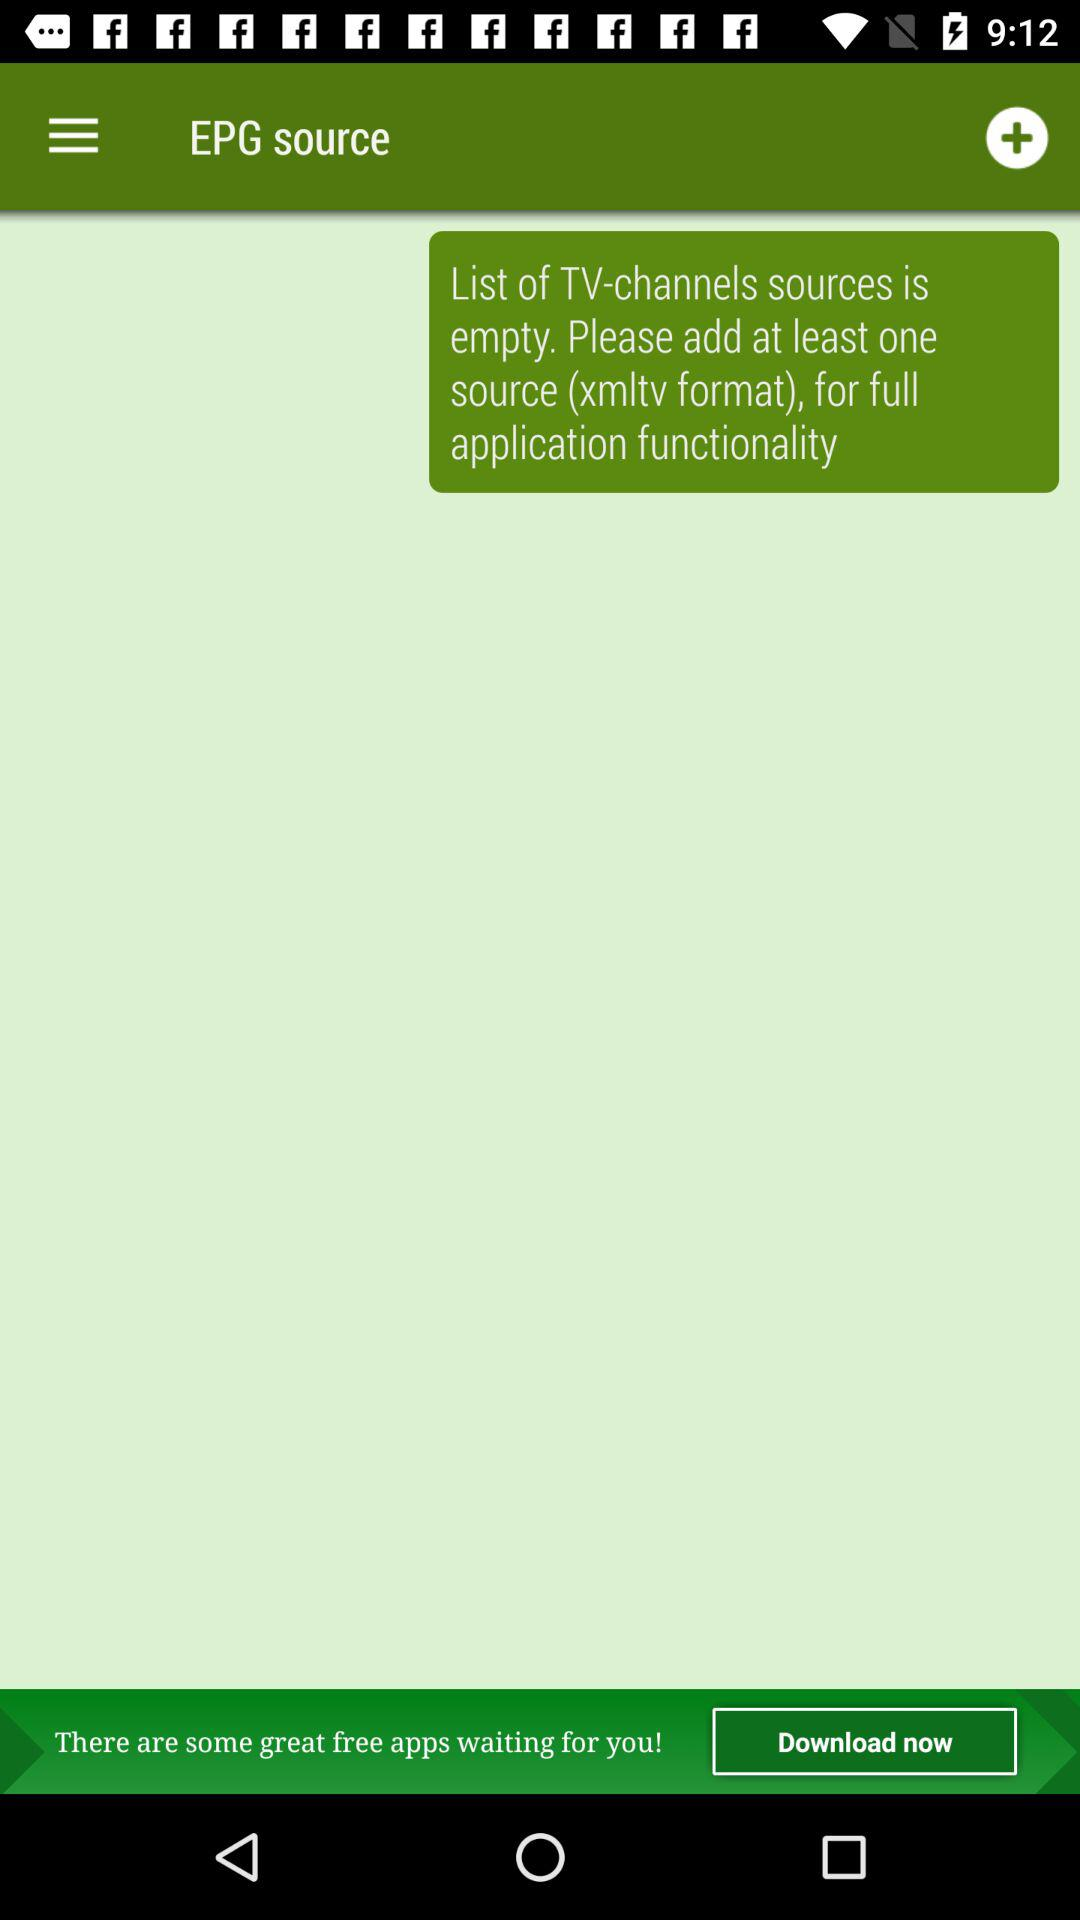How many free applications can be downloaded?
When the provided information is insufficient, respond with <no answer>. <no answer> 